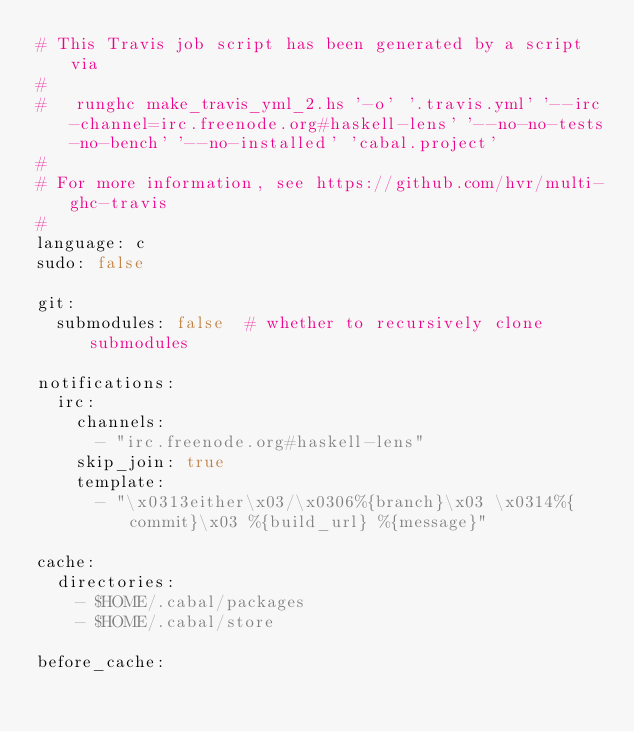Convert code to text. <code><loc_0><loc_0><loc_500><loc_500><_YAML_># This Travis job script has been generated by a script via
#
#   runghc make_travis_yml_2.hs '-o' '.travis.yml' '--irc-channel=irc.freenode.org#haskell-lens' '--no-no-tests-no-bench' '--no-installed' 'cabal.project'
#
# For more information, see https://github.com/hvr/multi-ghc-travis
#
language: c
sudo: false

git:
  submodules: false  # whether to recursively clone submodules

notifications:
  irc:
    channels:
      - "irc.freenode.org#haskell-lens"
    skip_join: true
    template:
      - "\x0313either\x03/\x0306%{branch}\x03 \x0314%{commit}\x03 %{build_url} %{message}"

cache:
  directories:
    - $HOME/.cabal/packages
    - $HOME/.cabal/store

before_cache:</code> 